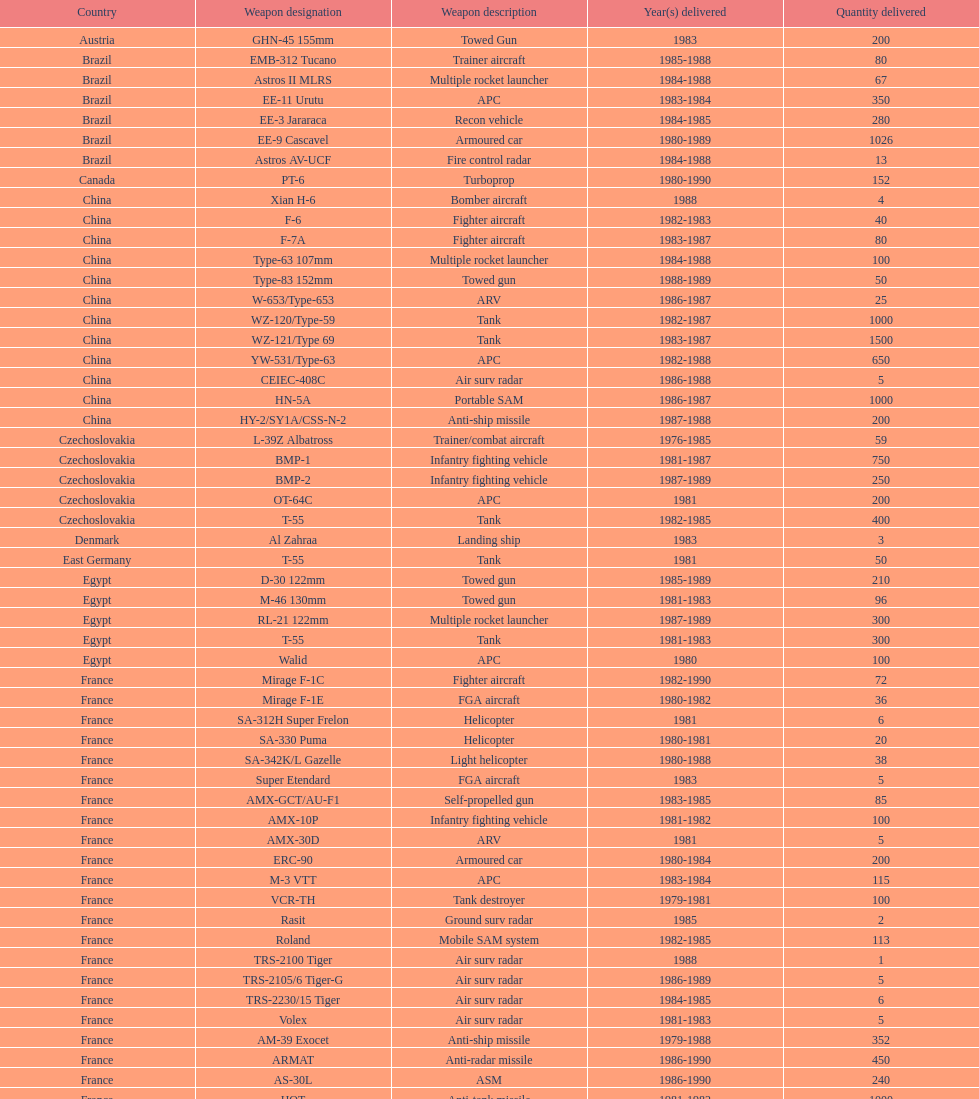Which was the first country to sell weapons to iraq? Czechoslovakia. 